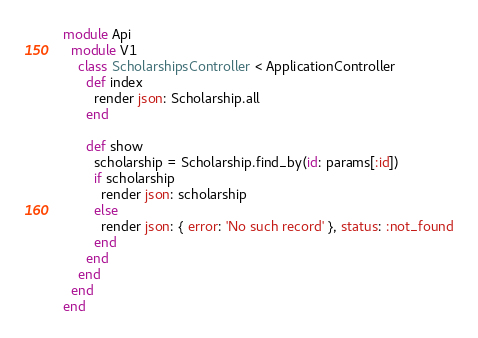<code> <loc_0><loc_0><loc_500><loc_500><_Ruby_>module Api
  module V1
    class ScholarshipsController < ApplicationController
      def index
        render json: Scholarship.all
      end

      def show
        scholarship = Scholarship.find_by(id: params[:id])
        if scholarship
          render json: scholarship
        else
          render json: { error: 'No such record' }, status: :not_found
        end
      end
    end
  end
end
</code> 